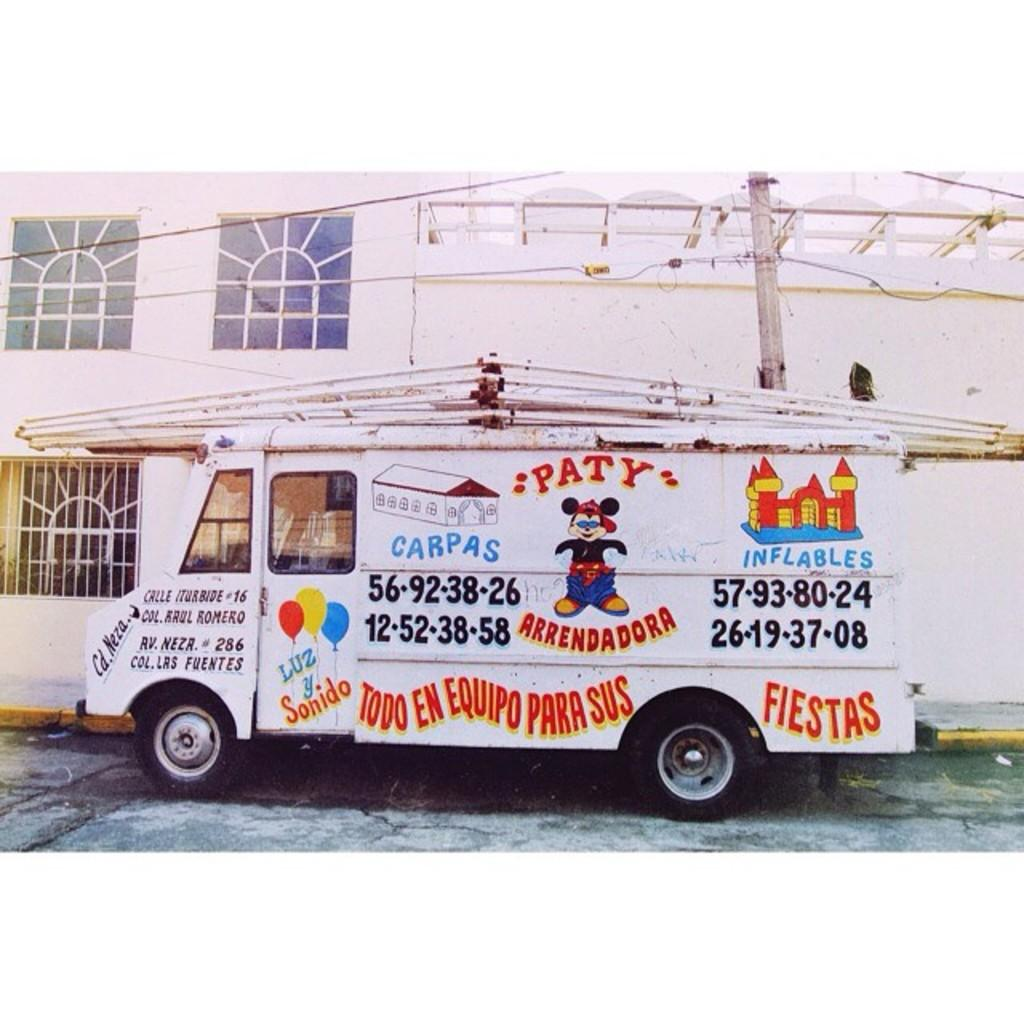<image>
Present a compact description of the photo's key features. A white truck carries party supplies such as Inflables and Carpas. 